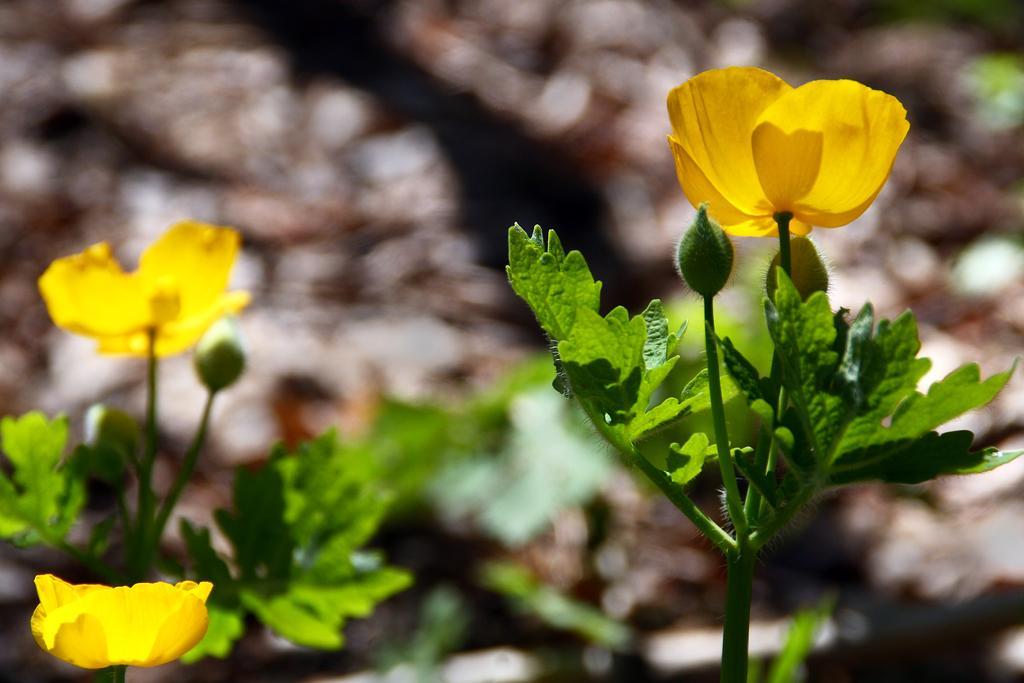In one or two sentences, can you explain what this image depicts? In this image we can see flowers and buds to the plants and a blurry background. 